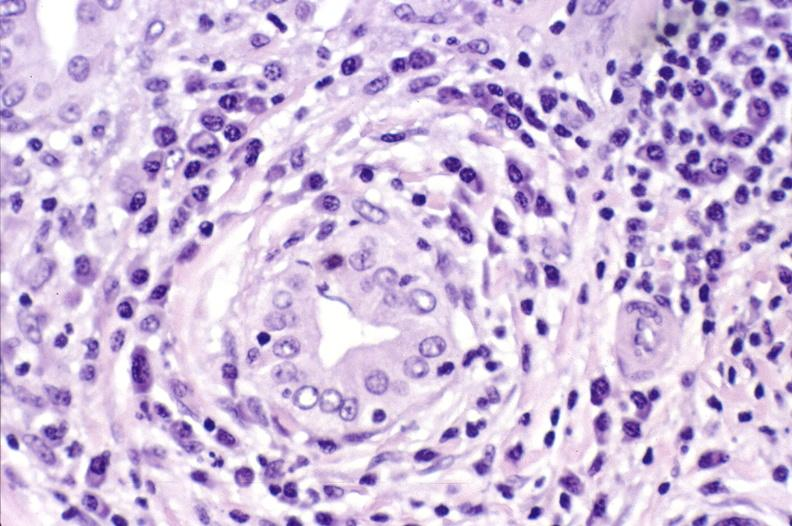what does this image show?
Answer the question using a single word or phrase. Primary biliary cirrhosis 